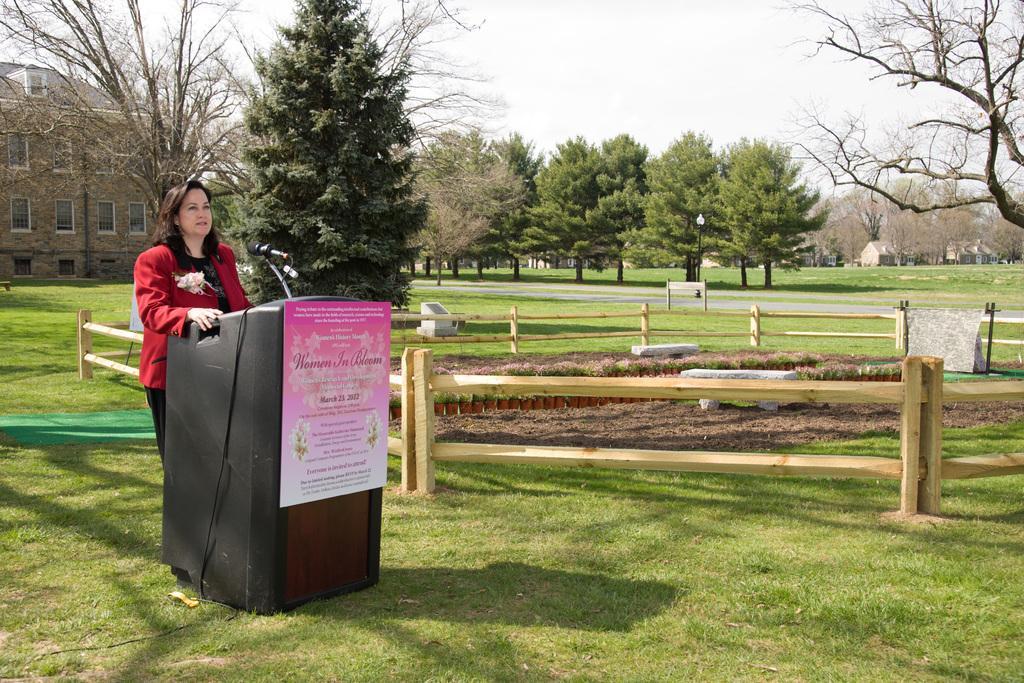How would you summarize this image in a sentence or two? In this image a woman is standing on the grassland. Before her there is a podium having a mike on it. A board is attached to the podium. On the board there is some text. Beside the woman there is a fence. There are few pots having plants. There are benches on the land. Right side there is a cloth on the metal rod. Right side there is a road. Beside there is a board attached to the poles. There is a street light on the grassland. Background there are trees and buildings. 